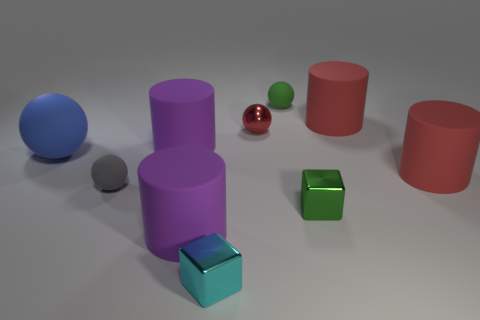Subtract 1 cylinders. How many cylinders are left? 3 Subtract all green spheres. How many spheres are left? 3 Subtract all blue spheres. How many spheres are left? 3 Subtract all cyan balls. Subtract all green cubes. How many balls are left? 4 Subtract all blocks. How many objects are left? 8 Subtract all cyan metal things. Subtract all small green blocks. How many objects are left? 8 Add 1 tiny metal blocks. How many tiny metal blocks are left? 3 Add 6 small red metal objects. How many small red metal objects exist? 7 Subtract 1 green blocks. How many objects are left? 9 